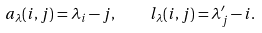Convert formula to latex. <formula><loc_0><loc_0><loc_500><loc_500>a _ { \lambda } ( i , j ) = \lambda _ { i } - j , \quad l _ { \lambda } ( i , j ) = \lambda ^ { \prime } _ { j } - i .</formula> 